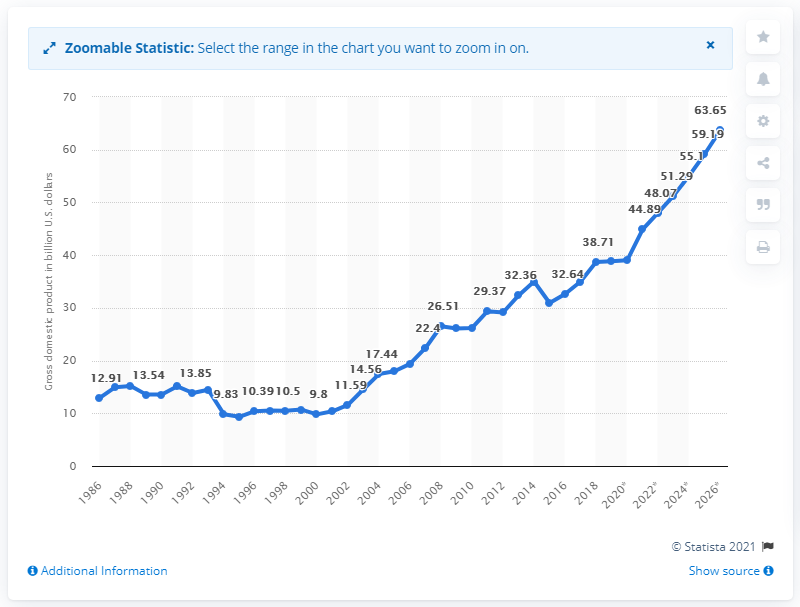Outline some significant characteristics in this image. According to data from 2019, the gross domestic product (GDP) of Cameroon was 39.02. 